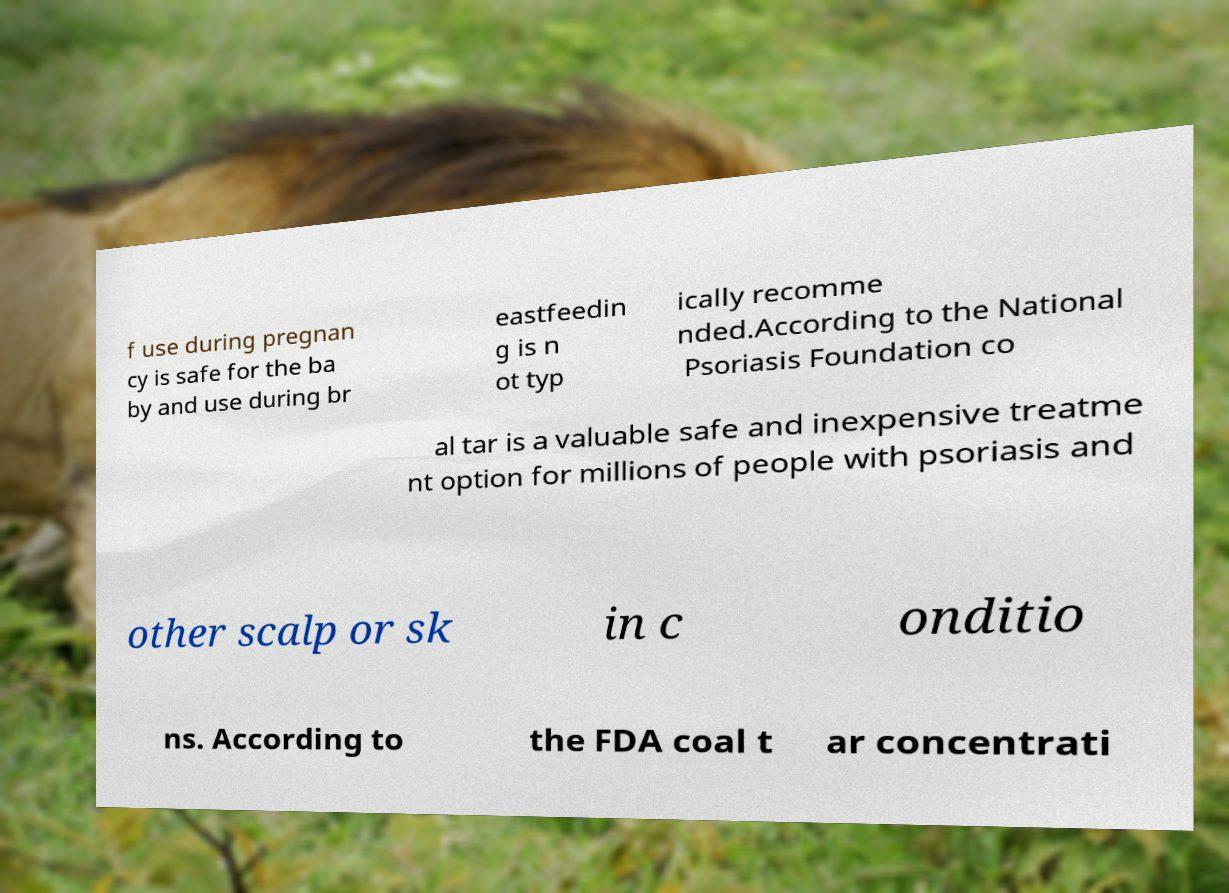Please identify and transcribe the text found in this image. f use during pregnan cy is safe for the ba by and use during br eastfeedin g is n ot typ ically recomme nded.According to the National Psoriasis Foundation co al tar is a valuable safe and inexpensive treatme nt option for millions of people with psoriasis and other scalp or sk in c onditio ns. According to the FDA coal t ar concentrati 